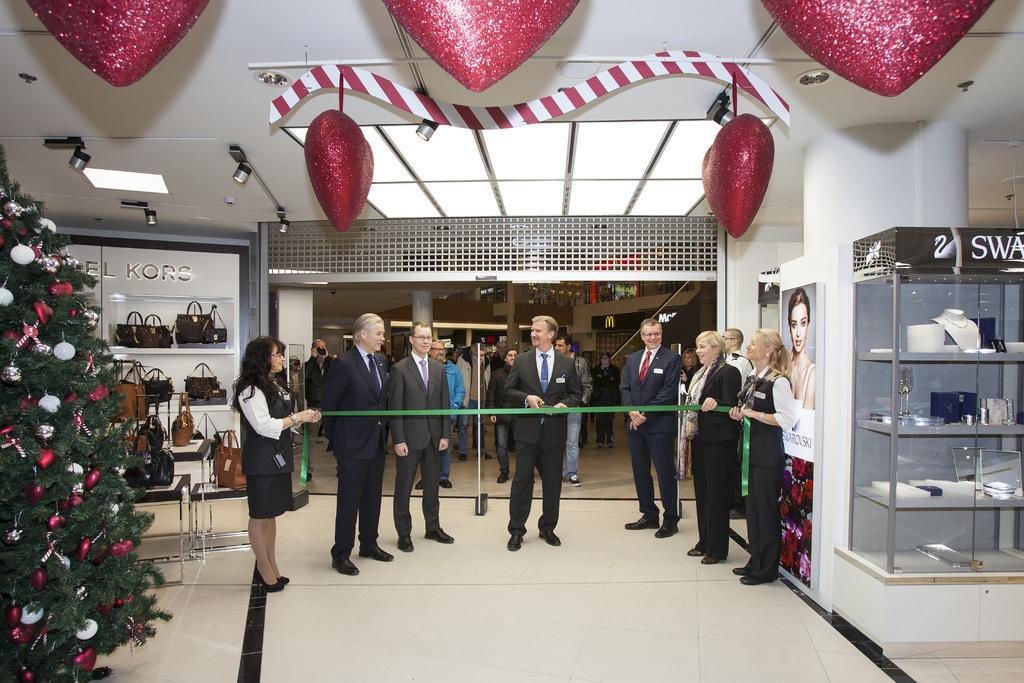Could you give a brief overview of what you see in this image? In this image there are people standing, behind a ribbon and two people are holding the ribbon, on the left side there is a Christmas tree, on the right side there is a glass cabinet in that there is jewelry, at the top there is a ceiling for that ceiling there are lights and heart symbols. 